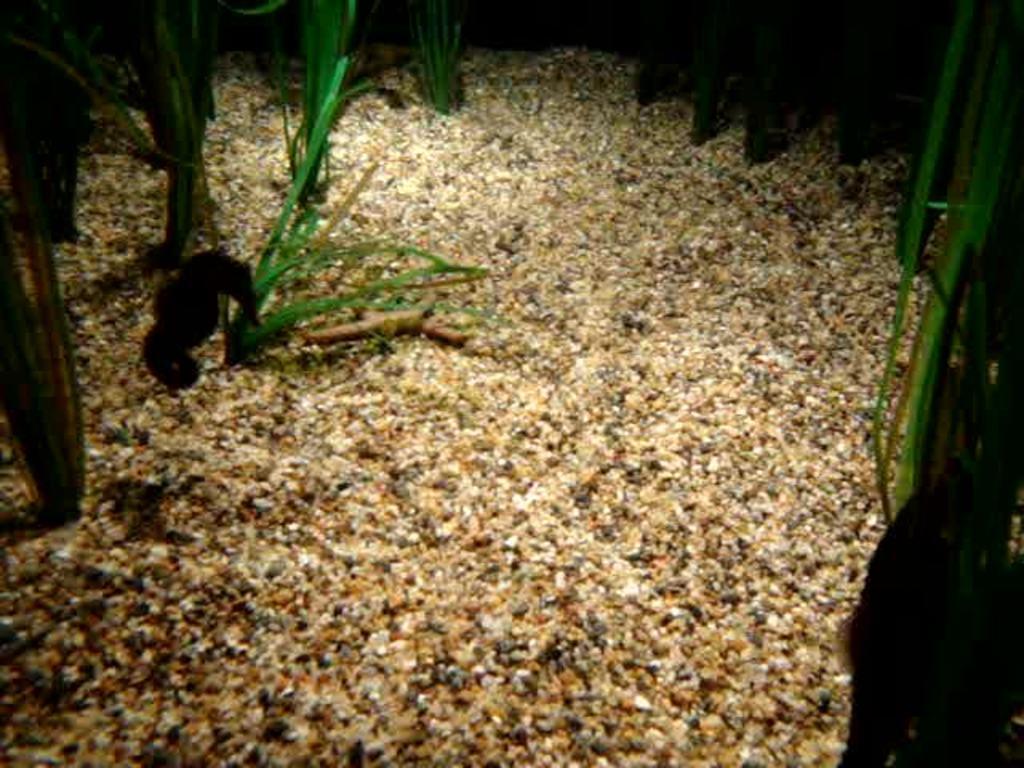Could you give a brief overview of what you see in this image? In this image I can see planets on the ground. This image is taken during night. 